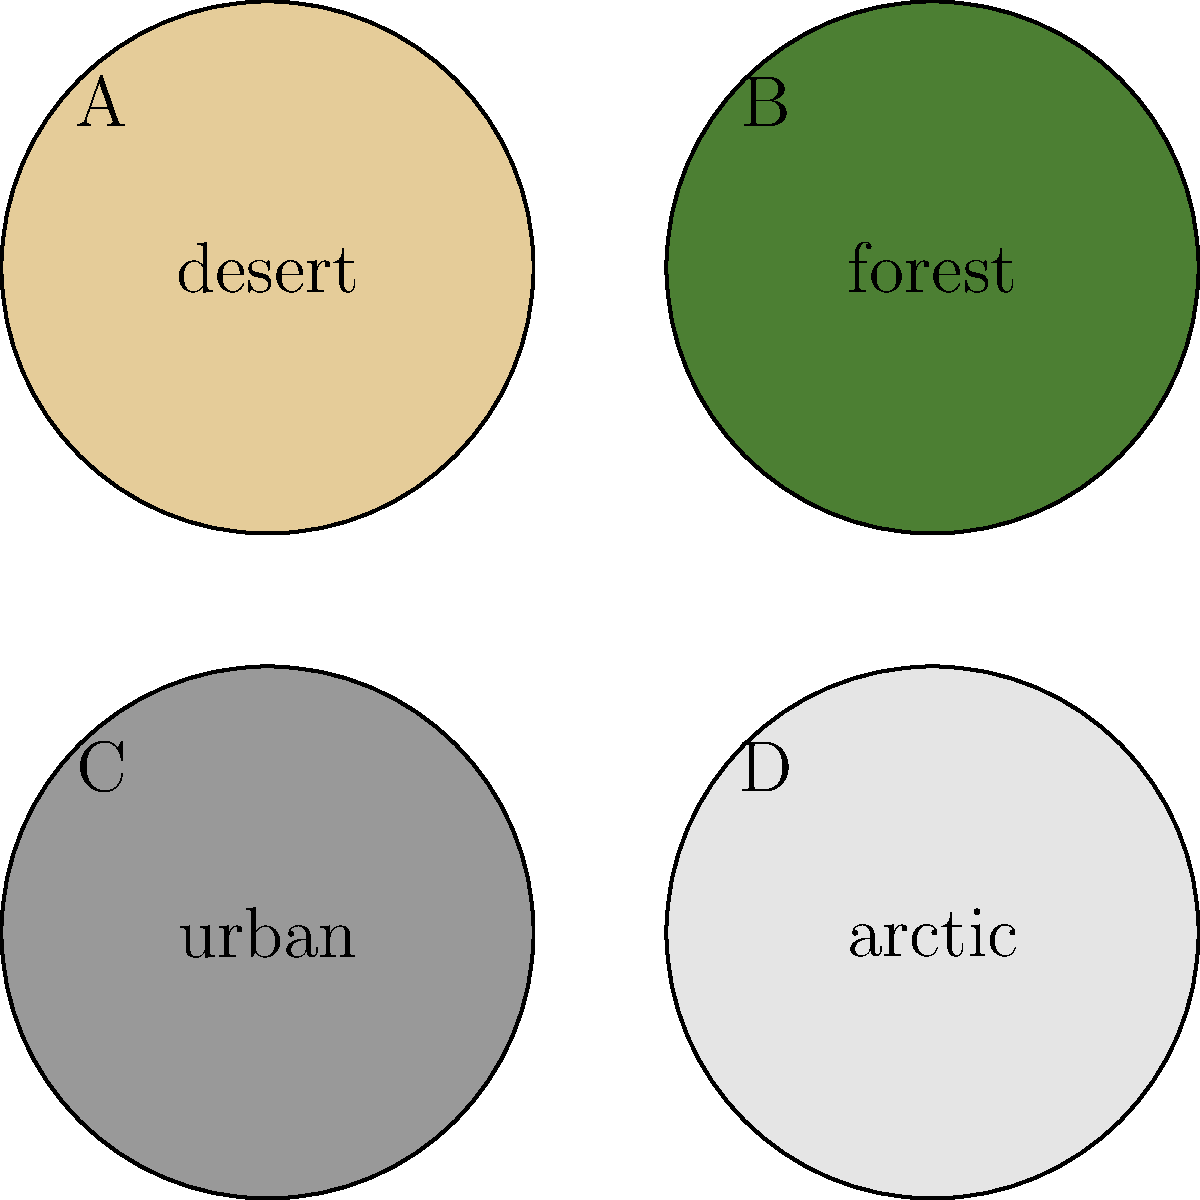As an aspiring artist inspired by military techniques, you're creating a series of camouflage-inspired artworks. Which pattern (A, B, C, or D) would be most effective for a piece depicting a soldier blending into a dense jungle environment? To answer this question, we need to consider the characteristics of a dense jungle environment and match it to the most suitable camouflage pattern:

1. Jungle environments are typically characterized by:
   - Dense vegetation
   - Dark green and brown colors
   - Varied textures from leaves, bark, and shadows

2. Analyzing the given patterns:
   A. Desert: Light tan color, suitable for arid environments
   B. Forest: Dark green color, ideal for wooded areas
   C. Urban: Gray color, designed for city environments
   D. Arctic: White color, meant for snowy landscapes

3. Comparing the patterns to a jungle environment:
   - The forest pattern (B) is the closest match due to its dark green color
   - It would provide the best concealment among dense foliage

4. The other patterns would stand out in a jungle:
   - Desert (A) is too light
   - Urban (C) is too gray
   - Arctic (D) is too white

5. Therefore, the most effective pattern for a dense jungle environment is the forest pattern (B).
Answer: B 